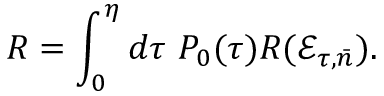Convert formula to latex. <formula><loc_0><loc_0><loc_500><loc_500>R = \int _ { 0 } ^ { \eta } d \tau P _ { 0 } ( \tau ) R ( \mathcal { E } _ { \tau , \bar { n } } ) .</formula> 